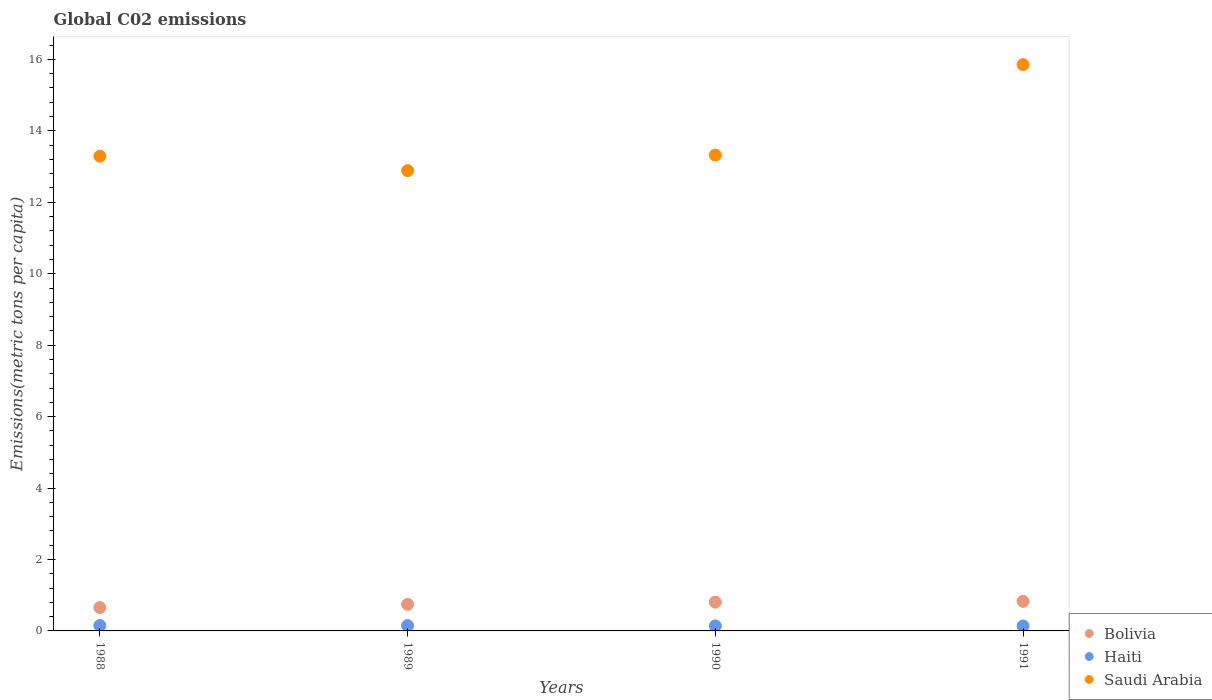Is the number of dotlines equal to the number of legend labels?
Provide a succinct answer. Yes. What is the amount of CO2 emitted in in Haiti in 1991?
Give a very brief answer. 0.14. Across all years, what is the maximum amount of CO2 emitted in in Saudi Arabia?
Provide a short and direct response. 15.85. Across all years, what is the minimum amount of CO2 emitted in in Haiti?
Your response must be concise. 0.14. In which year was the amount of CO2 emitted in in Bolivia maximum?
Give a very brief answer. 1991. What is the total amount of CO2 emitted in in Bolivia in the graph?
Ensure brevity in your answer.  3.03. What is the difference between the amount of CO2 emitted in in Haiti in 1990 and that in 1991?
Your response must be concise. 0. What is the difference between the amount of CO2 emitted in in Bolivia in 1991 and the amount of CO2 emitted in in Haiti in 1989?
Give a very brief answer. 0.68. What is the average amount of CO2 emitted in in Saudi Arabia per year?
Offer a very short reply. 13.84. In the year 1990, what is the difference between the amount of CO2 emitted in in Bolivia and amount of CO2 emitted in in Saudi Arabia?
Your answer should be compact. -12.51. What is the ratio of the amount of CO2 emitted in in Haiti in 1988 to that in 1991?
Keep it short and to the point. 1.09. Is the amount of CO2 emitted in in Haiti in 1989 less than that in 1990?
Keep it short and to the point. No. Is the difference between the amount of CO2 emitted in in Bolivia in 1988 and 1989 greater than the difference between the amount of CO2 emitted in in Saudi Arabia in 1988 and 1989?
Your answer should be very brief. No. What is the difference between the highest and the second highest amount of CO2 emitted in in Saudi Arabia?
Give a very brief answer. 2.53. What is the difference between the highest and the lowest amount of CO2 emitted in in Haiti?
Give a very brief answer. 0.01. In how many years, is the amount of CO2 emitted in in Haiti greater than the average amount of CO2 emitted in in Haiti taken over all years?
Provide a succinct answer. 2. Is the amount of CO2 emitted in in Saudi Arabia strictly greater than the amount of CO2 emitted in in Haiti over the years?
Give a very brief answer. Yes. How many years are there in the graph?
Give a very brief answer. 4. How many legend labels are there?
Offer a very short reply. 3. How are the legend labels stacked?
Offer a very short reply. Vertical. What is the title of the graph?
Offer a very short reply. Global C02 emissions. Does "Norway" appear as one of the legend labels in the graph?
Offer a very short reply. No. What is the label or title of the Y-axis?
Keep it short and to the point. Emissions(metric tons per capita). What is the Emissions(metric tons per capita) in Bolivia in 1988?
Provide a short and direct response. 0.65. What is the Emissions(metric tons per capita) of Haiti in 1988?
Give a very brief answer. 0.15. What is the Emissions(metric tons per capita) in Saudi Arabia in 1988?
Your answer should be very brief. 13.29. What is the Emissions(metric tons per capita) of Bolivia in 1989?
Make the answer very short. 0.74. What is the Emissions(metric tons per capita) in Haiti in 1989?
Provide a short and direct response. 0.15. What is the Emissions(metric tons per capita) in Saudi Arabia in 1989?
Your answer should be very brief. 12.89. What is the Emissions(metric tons per capita) in Bolivia in 1990?
Offer a terse response. 0.81. What is the Emissions(metric tons per capita) of Haiti in 1990?
Your answer should be very brief. 0.14. What is the Emissions(metric tons per capita) of Saudi Arabia in 1990?
Ensure brevity in your answer.  13.32. What is the Emissions(metric tons per capita) of Bolivia in 1991?
Give a very brief answer. 0.83. What is the Emissions(metric tons per capita) of Haiti in 1991?
Your answer should be very brief. 0.14. What is the Emissions(metric tons per capita) in Saudi Arabia in 1991?
Provide a succinct answer. 15.85. Across all years, what is the maximum Emissions(metric tons per capita) in Bolivia?
Your response must be concise. 0.83. Across all years, what is the maximum Emissions(metric tons per capita) in Haiti?
Provide a short and direct response. 0.15. Across all years, what is the maximum Emissions(metric tons per capita) of Saudi Arabia?
Offer a terse response. 15.85. Across all years, what is the minimum Emissions(metric tons per capita) of Bolivia?
Offer a very short reply. 0.65. Across all years, what is the minimum Emissions(metric tons per capita) in Haiti?
Provide a succinct answer. 0.14. Across all years, what is the minimum Emissions(metric tons per capita) in Saudi Arabia?
Give a very brief answer. 12.89. What is the total Emissions(metric tons per capita) of Bolivia in the graph?
Your response must be concise. 3.03. What is the total Emissions(metric tons per capita) of Haiti in the graph?
Offer a very short reply. 0.58. What is the total Emissions(metric tons per capita) of Saudi Arabia in the graph?
Offer a very short reply. 55.35. What is the difference between the Emissions(metric tons per capita) of Bolivia in 1988 and that in 1989?
Your answer should be compact. -0.09. What is the difference between the Emissions(metric tons per capita) in Saudi Arabia in 1988 and that in 1989?
Offer a very short reply. 0.41. What is the difference between the Emissions(metric tons per capita) in Bolivia in 1988 and that in 1990?
Your answer should be compact. -0.15. What is the difference between the Emissions(metric tons per capita) of Haiti in 1988 and that in 1990?
Your answer should be compact. 0.01. What is the difference between the Emissions(metric tons per capita) in Saudi Arabia in 1988 and that in 1990?
Your response must be concise. -0.03. What is the difference between the Emissions(metric tons per capita) in Bolivia in 1988 and that in 1991?
Offer a very short reply. -0.18. What is the difference between the Emissions(metric tons per capita) in Haiti in 1988 and that in 1991?
Offer a very short reply. 0.01. What is the difference between the Emissions(metric tons per capita) of Saudi Arabia in 1988 and that in 1991?
Your answer should be very brief. -2.56. What is the difference between the Emissions(metric tons per capita) in Bolivia in 1989 and that in 1990?
Your answer should be very brief. -0.06. What is the difference between the Emissions(metric tons per capita) in Haiti in 1989 and that in 1990?
Keep it short and to the point. 0.01. What is the difference between the Emissions(metric tons per capita) in Saudi Arabia in 1989 and that in 1990?
Offer a very short reply. -0.43. What is the difference between the Emissions(metric tons per capita) in Bolivia in 1989 and that in 1991?
Give a very brief answer. -0.09. What is the difference between the Emissions(metric tons per capita) in Haiti in 1989 and that in 1991?
Your answer should be compact. 0.01. What is the difference between the Emissions(metric tons per capita) in Saudi Arabia in 1989 and that in 1991?
Offer a very short reply. -2.97. What is the difference between the Emissions(metric tons per capita) in Bolivia in 1990 and that in 1991?
Ensure brevity in your answer.  -0.02. What is the difference between the Emissions(metric tons per capita) in Haiti in 1990 and that in 1991?
Provide a short and direct response. 0. What is the difference between the Emissions(metric tons per capita) in Saudi Arabia in 1990 and that in 1991?
Give a very brief answer. -2.53. What is the difference between the Emissions(metric tons per capita) in Bolivia in 1988 and the Emissions(metric tons per capita) in Haiti in 1989?
Your answer should be compact. 0.5. What is the difference between the Emissions(metric tons per capita) in Bolivia in 1988 and the Emissions(metric tons per capita) in Saudi Arabia in 1989?
Provide a short and direct response. -12.23. What is the difference between the Emissions(metric tons per capita) in Haiti in 1988 and the Emissions(metric tons per capita) in Saudi Arabia in 1989?
Your response must be concise. -12.74. What is the difference between the Emissions(metric tons per capita) of Bolivia in 1988 and the Emissions(metric tons per capita) of Haiti in 1990?
Ensure brevity in your answer.  0.51. What is the difference between the Emissions(metric tons per capita) in Bolivia in 1988 and the Emissions(metric tons per capita) in Saudi Arabia in 1990?
Offer a terse response. -12.67. What is the difference between the Emissions(metric tons per capita) of Haiti in 1988 and the Emissions(metric tons per capita) of Saudi Arabia in 1990?
Provide a succinct answer. -13.17. What is the difference between the Emissions(metric tons per capita) of Bolivia in 1988 and the Emissions(metric tons per capita) of Haiti in 1991?
Give a very brief answer. 0.52. What is the difference between the Emissions(metric tons per capita) of Bolivia in 1988 and the Emissions(metric tons per capita) of Saudi Arabia in 1991?
Your answer should be very brief. -15.2. What is the difference between the Emissions(metric tons per capita) in Haiti in 1988 and the Emissions(metric tons per capita) in Saudi Arabia in 1991?
Keep it short and to the point. -15.7. What is the difference between the Emissions(metric tons per capita) in Bolivia in 1989 and the Emissions(metric tons per capita) in Haiti in 1990?
Make the answer very short. 0.6. What is the difference between the Emissions(metric tons per capita) of Bolivia in 1989 and the Emissions(metric tons per capita) of Saudi Arabia in 1990?
Provide a short and direct response. -12.58. What is the difference between the Emissions(metric tons per capita) in Haiti in 1989 and the Emissions(metric tons per capita) in Saudi Arabia in 1990?
Give a very brief answer. -13.17. What is the difference between the Emissions(metric tons per capita) in Bolivia in 1989 and the Emissions(metric tons per capita) in Haiti in 1991?
Give a very brief answer. 0.61. What is the difference between the Emissions(metric tons per capita) of Bolivia in 1989 and the Emissions(metric tons per capita) of Saudi Arabia in 1991?
Give a very brief answer. -15.11. What is the difference between the Emissions(metric tons per capita) in Haiti in 1989 and the Emissions(metric tons per capita) in Saudi Arabia in 1991?
Make the answer very short. -15.7. What is the difference between the Emissions(metric tons per capita) in Bolivia in 1990 and the Emissions(metric tons per capita) in Haiti in 1991?
Provide a short and direct response. 0.67. What is the difference between the Emissions(metric tons per capita) of Bolivia in 1990 and the Emissions(metric tons per capita) of Saudi Arabia in 1991?
Keep it short and to the point. -15.05. What is the difference between the Emissions(metric tons per capita) of Haiti in 1990 and the Emissions(metric tons per capita) of Saudi Arabia in 1991?
Offer a terse response. -15.71. What is the average Emissions(metric tons per capita) in Bolivia per year?
Your response must be concise. 0.76. What is the average Emissions(metric tons per capita) in Haiti per year?
Give a very brief answer. 0.14. What is the average Emissions(metric tons per capita) of Saudi Arabia per year?
Keep it short and to the point. 13.84. In the year 1988, what is the difference between the Emissions(metric tons per capita) of Bolivia and Emissions(metric tons per capita) of Haiti?
Give a very brief answer. 0.5. In the year 1988, what is the difference between the Emissions(metric tons per capita) in Bolivia and Emissions(metric tons per capita) in Saudi Arabia?
Your response must be concise. -12.64. In the year 1988, what is the difference between the Emissions(metric tons per capita) of Haiti and Emissions(metric tons per capita) of Saudi Arabia?
Give a very brief answer. -13.14. In the year 1989, what is the difference between the Emissions(metric tons per capita) in Bolivia and Emissions(metric tons per capita) in Haiti?
Your response must be concise. 0.59. In the year 1989, what is the difference between the Emissions(metric tons per capita) in Bolivia and Emissions(metric tons per capita) in Saudi Arabia?
Give a very brief answer. -12.14. In the year 1989, what is the difference between the Emissions(metric tons per capita) of Haiti and Emissions(metric tons per capita) of Saudi Arabia?
Provide a succinct answer. -12.74. In the year 1990, what is the difference between the Emissions(metric tons per capita) in Bolivia and Emissions(metric tons per capita) in Haiti?
Your answer should be compact. 0.67. In the year 1990, what is the difference between the Emissions(metric tons per capita) in Bolivia and Emissions(metric tons per capita) in Saudi Arabia?
Give a very brief answer. -12.51. In the year 1990, what is the difference between the Emissions(metric tons per capita) in Haiti and Emissions(metric tons per capita) in Saudi Arabia?
Your response must be concise. -13.18. In the year 1991, what is the difference between the Emissions(metric tons per capita) in Bolivia and Emissions(metric tons per capita) in Haiti?
Offer a terse response. 0.69. In the year 1991, what is the difference between the Emissions(metric tons per capita) in Bolivia and Emissions(metric tons per capita) in Saudi Arabia?
Keep it short and to the point. -15.02. In the year 1991, what is the difference between the Emissions(metric tons per capita) of Haiti and Emissions(metric tons per capita) of Saudi Arabia?
Your answer should be very brief. -15.72. What is the ratio of the Emissions(metric tons per capita) in Bolivia in 1988 to that in 1989?
Give a very brief answer. 0.88. What is the ratio of the Emissions(metric tons per capita) in Haiti in 1988 to that in 1989?
Provide a succinct answer. 1.01. What is the ratio of the Emissions(metric tons per capita) of Saudi Arabia in 1988 to that in 1989?
Your answer should be compact. 1.03. What is the ratio of the Emissions(metric tons per capita) of Bolivia in 1988 to that in 1990?
Make the answer very short. 0.81. What is the ratio of the Emissions(metric tons per capita) in Haiti in 1988 to that in 1990?
Your response must be concise. 1.07. What is the ratio of the Emissions(metric tons per capita) in Bolivia in 1988 to that in 1991?
Provide a succinct answer. 0.79. What is the ratio of the Emissions(metric tons per capita) in Haiti in 1988 to that in 1991?
Ensure brevity in your answer.  1.09. What is the ratio of the Emissions(metric tons per capita) in Saudi Arabia in 1988 to that in 1991?
Offer a very short reply. 0.84. What is the ratio of the Emissions(metric tons per capita) of Bolivia in 1989 to that in 1990?
Provide a short and direct response. 0.92. What is the ratio of the Emissions(metric tons per capita) in Haiti in 1989 to that in 1990?
Provide a short and direct response. 1.07. What is the ratio of the Emissions(metric tons per capita) in Saudi Arabia in 1989 to that in 1990?
Your answer should be compact. 0.97. What is the ratio of the Emissions(metric tons per capita) in Bolivia in 1989 to that in 1991?
Your answer should be very brief. 0.9. What is the ratio of the Emissions(metric tons per capita) of Haiti in 1989 to that in 1991?
Your answer should be very brief. 1.08. What is the ratio of the Emissions(metric tons per capita) of Saudi Arabia in 1989 to that in 1991?
Your response must be concise. 0.81. What is the ratio of the Emissions(metric tons per capita) in Bolivia in 1990 to that in 1991?
Keep it short and to the point. 0.97. What is the ratio of the Emissions(metric tons per capita) of Haiti in 1990 to that in 1991?
Keep it short and to the point. 1.02. What is the ratio of the Emissions(metric tons per capita) of Saudi Arabia in 1990 to that in 1991?
Give a very brief answer. 0.84. What is the difference between the highest and the second highest Emissions(metric tons per capita) of Bolivia?
Your answer should be very brief. 0.02. What is the difference between the highest and the second highest Emissions(metric tons per capita) of Saudi Arabia?
Give a very brief answer. 2.53. What is the difference between the highest and the lowest Emissions(metric tons per capita) of Bolivia?
Your answer should be very brief. 0.18. What is the difference between the highest and the lowest Emissions(metric tons per capita) in Haiti?
Make the answer very short. 0.01. What is the difference between the highest and the lowest Emissions(metric tons per capita) of Saudi Arabia?
Your response must be concise. 2.97. 